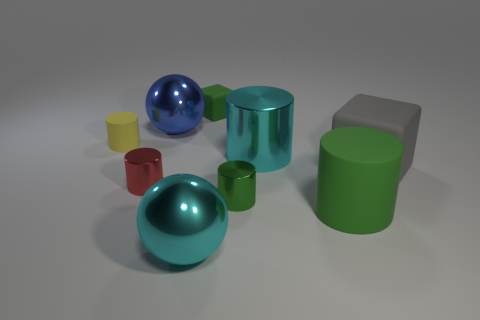What color is the metallic cylinder on the left side of the small shiny thing on the right side of the green cube?
Offer a very short reply. Red. How many green matte cubes are there?
Provide a succinct answer. 1. What number of rubber objects are on the left side of the green rubber block and in front of the cyan metallic cylinder?
Make the answer very short. 0. Are there any other things that are the same shape as the tiny red metallic thing?
Your response must be concise. Yes. Do the tiny rubber cylinder and the cube that is to the left of the green shiny object have the same color?
Your response must be concise. No. There is a green matte object behind the big cyan shiny cylinder; what shape is it?
Make the answer very short. Cube. How many other objects are there of the same material as the tiny green cube?
Ensure brevity in your answer.  3. What is the big green cylinder made of?
Give a very brief answer. Rubber. How many small objects are cyan matte cylinders or green matte things?
Provide a succinct answer. 1. What number of tiny green cylinders are on the right side of the gray block?
Make the answer very short. 0. 